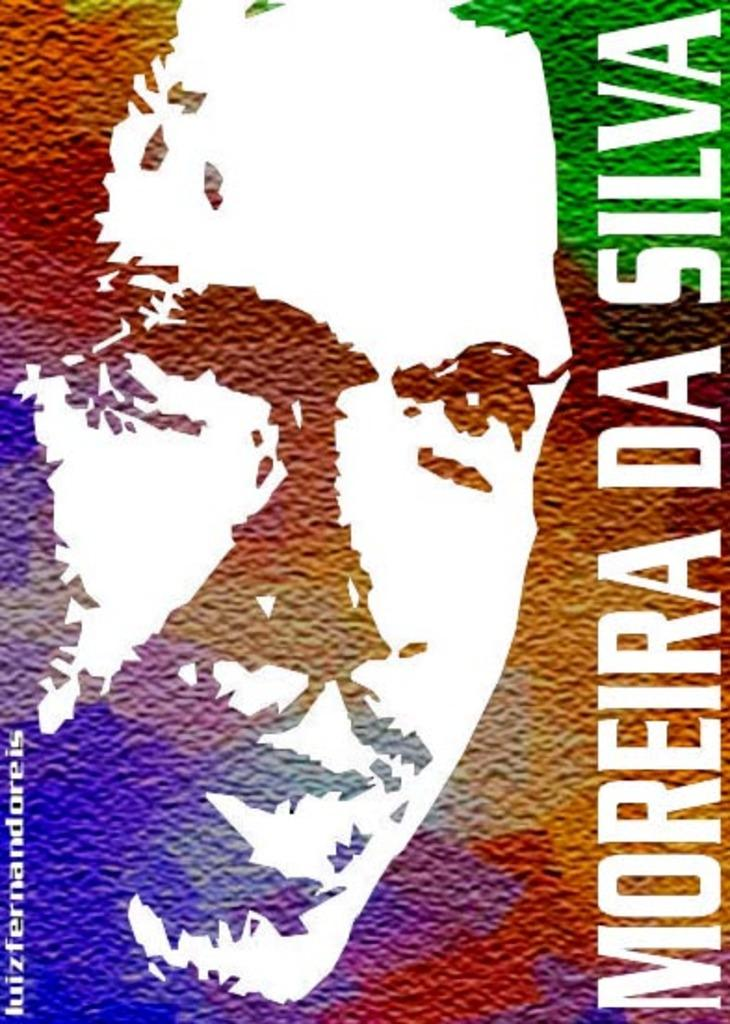<image>
Summarize the visual content of the image. A multicolored background has white letters on it spelling out moreira da silva. 